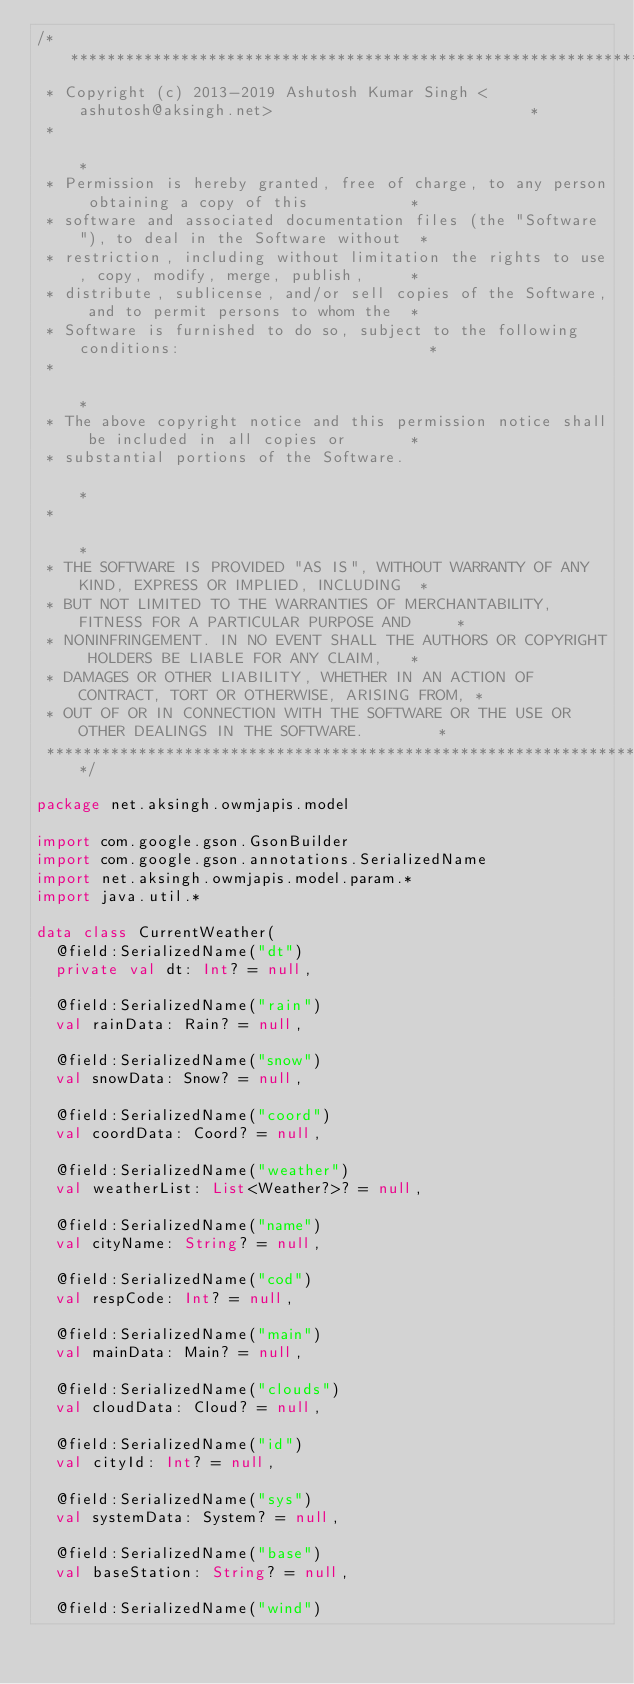<code> <loc_0><loc_0><loc_500><loc_500><_Kotlin_>/**************************************************************************************************
 * Copyright (c) 2013-2019 Ashutosh Kumar Singh <ashutosh@aksingh.net>                            *
 *                                                                                                *
 * Permission is hereby granted, free of charge, to any person obtaining a copy of this           *
 * software and associated documentation files (the "Software"), to deal in the Software without  *
 * restriction, including without limitation the rights to use, copy, modify, merge, publish,     *
 * distribute, sublicense, and/or sell copies of the Software, and to permit persons to whom the  *
 * Software is furnished to do so, subject to the following conditions:                           *
 *                                                                                                *
 * The above copyright notice and this permission notice shall be included in all copies or       *
 * substantial portions of the Software.                                                          *
 *                                                                                                *
 * THE SOFTWARE IS PROVIDED "AS IS", WITHOUT WARRANTY OF ANY KIND, EXPRESS OR IMPLIED, INCLUDING  *
 * BUT NOT LIMITED TO THE WARRANTIES OF MERCHANTABILITY, FITNESS FOR A PARTICULAR PURPOSE AND     *
 * NONINFRINGEMENT. IN NO EVENT SHALL THE AUTHORS OR COPYRIGHT HOLDERS BE LIABLE FOR ANY CLAIM,   *
 * DAMAGES OR OTHER LIABILITY, WHETHER IN AN ACTION OF CONTRACT, TORT OR OTHERWISE, ARISING FROM, *
 * OUT OF OR IN CONNECTION WITH THE SOFTWARE OR THE USE OR OTHER DEALINGS IN THE SOFTWARE.        *
 **************************************************************************************************/

package net.aksingh.owmjapis.model

import com.google.gson.GsonBuilder
import com.google.gson.annotations.SerializedName
import net.aksingh.owmjapis.model.param.*
import java.util.*

data class CurrentWeather(
  @field:SerializedName("dt")
  private val dt: Int? = null,

  @field:SerializedName("rain")
  val rainData: Rain? = null,

  @field:SerializedName("snow")
  val snowData: Snow? = null,

  @field:SerializedName("coord")
  val coordData: Coord? = null,

  @field:SerializedName("weather")
  val weatherList: List<Weather?>? = null,

  @field:SerializedName("name")
  val cityName: String? = null,

  @field:SerializedName("cod")
  val respCode: Int? = null,

  @field:SerializedName("main")
  val mainData: Main? = null,

  @field:SerializedName("clouds")
  val cloudData: Cloud? = null,

  @field:SerializedName("id")
  val cityId: Int? = null,

  @field:SerializedName("sys")
  val systemData: System? = null,

  @field:SerializedName("base")
  val baseStation: String? = null,

  @field:SerializedName("wind")</code> 